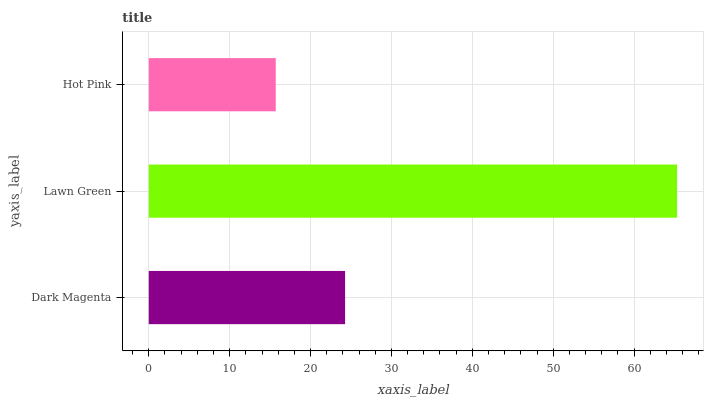Is Hot Pink the minimum?
Answer yes or no. Yes. Is Lawn Green the maximum?
Answer yes or no. Yes. Is Lawn Green the minimum?
Answer yes or no. No. Is Hot Pink the maximum?
Answer yes or no. No. Is Lawn Green greater than Hot Pink?
Answer yes or no. Yes. Is Hot Pink less than Lawn Green?
Answer yes or no. Yes. Is Hot Pink greater than Lawn Green?
Answer yes or no. No. Is Lawn Green less than Hot Pink?
Answer yes or no. No. Is Dark Magenta the high median?
Answer yes or no. Yes. Is Dark Magenta the low median?
Answer yes or no. Yes. Is Lawn Green the high median?
Answer yes or no. No. Is Lawn Green the low median?
Answer yes or no. No. 